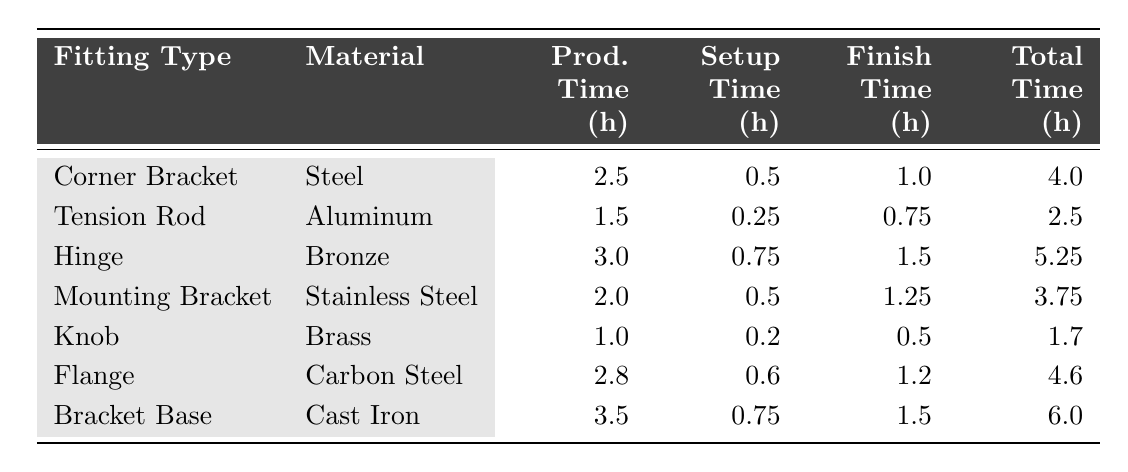What is the production time for a Tension Rod? The production time for a Tension Rod is listed in the table under "Prod. Time (h)," which shows 1.5 hours.
Answer: 1.5 hours Which fitting type requires the most total production time? The table shows that the Bracket Base has the highest Total Time at 6.0 hours, indicating it requires the most total time compared to the other fittings.
Answer: Bracket Base What is the setup time for a Knob? The setup time for a Knob is specified in the table and recorded as 0.2 hours.
Answer: 0.2 hours Is the production time for a Flange more than 2 hours? The table indicates that the production time for a Flange is 2.8 hours, which is indeed greater than 2 hours.
Answer: Yes What is the average total cycle time of all the fittings? To find the average, we sum all Total Cycle Times: (4.0 + 2.5 + 5.25 + 3.75 + 1.7 + 4.6 + 6.0) = 27.0 hours. Dividing by the 7 fittings gives an average of 27.0 / 7 ≈ 3.86 hours.
Answer: 3.86 hours Which fitting type has the least finish time? The table lists the finish times for each fitting, with the Knob having the least at 0.5 hours.
Answer: Knob What is the difference in production time between the Corner Bracket and the Hinge? The Corner Bracket has a production time of 2.5 hours, while the Hinge has 3.0 hours. The difference is 3.0 - 2.5 = 0.5 hours.
Answer: 0.5 hours How many fittings have a production time of less than 2 hours? By examining the table, only the Knob has a production time of 1.0 hours, which is the only fitting listed below 2 hours.
Answer: 1 fitting What is the total setup time for all fittings combined? The total setup time sums to: (0.5 + 0.25 + 0.75 + 0.5 + 0.2 + 0.6 + 0.75) = 3.55 hours total setup time across all fittings.
Answer: 3.55 hours Which material corresponds to the Mounting Bracket? The Mounting Bracket's material is defined in the table as Stainless Steel.
Answer: Stainless Steel 